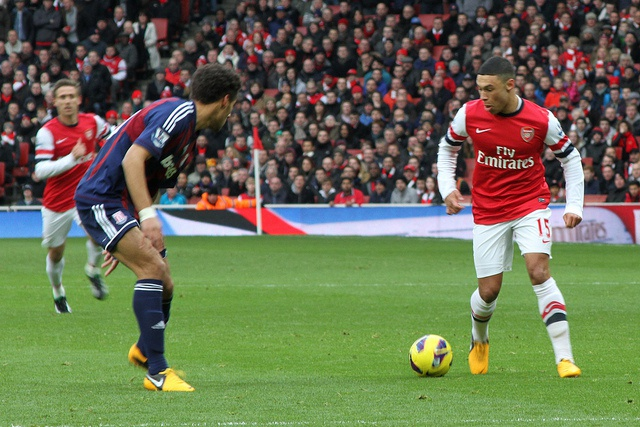Describe the objects in this image and their specific colors. I can see people in darkgray, black, gray, and maroon tones, people in darkgray, lightgray, brown, and maroon tones, people in darkgray, black, navy, tan, and gray tones, people in darkgray, brown, lightgray, and gray tones, and sports ball in darkgray, khaki, yellow, and olive tones in this image. 